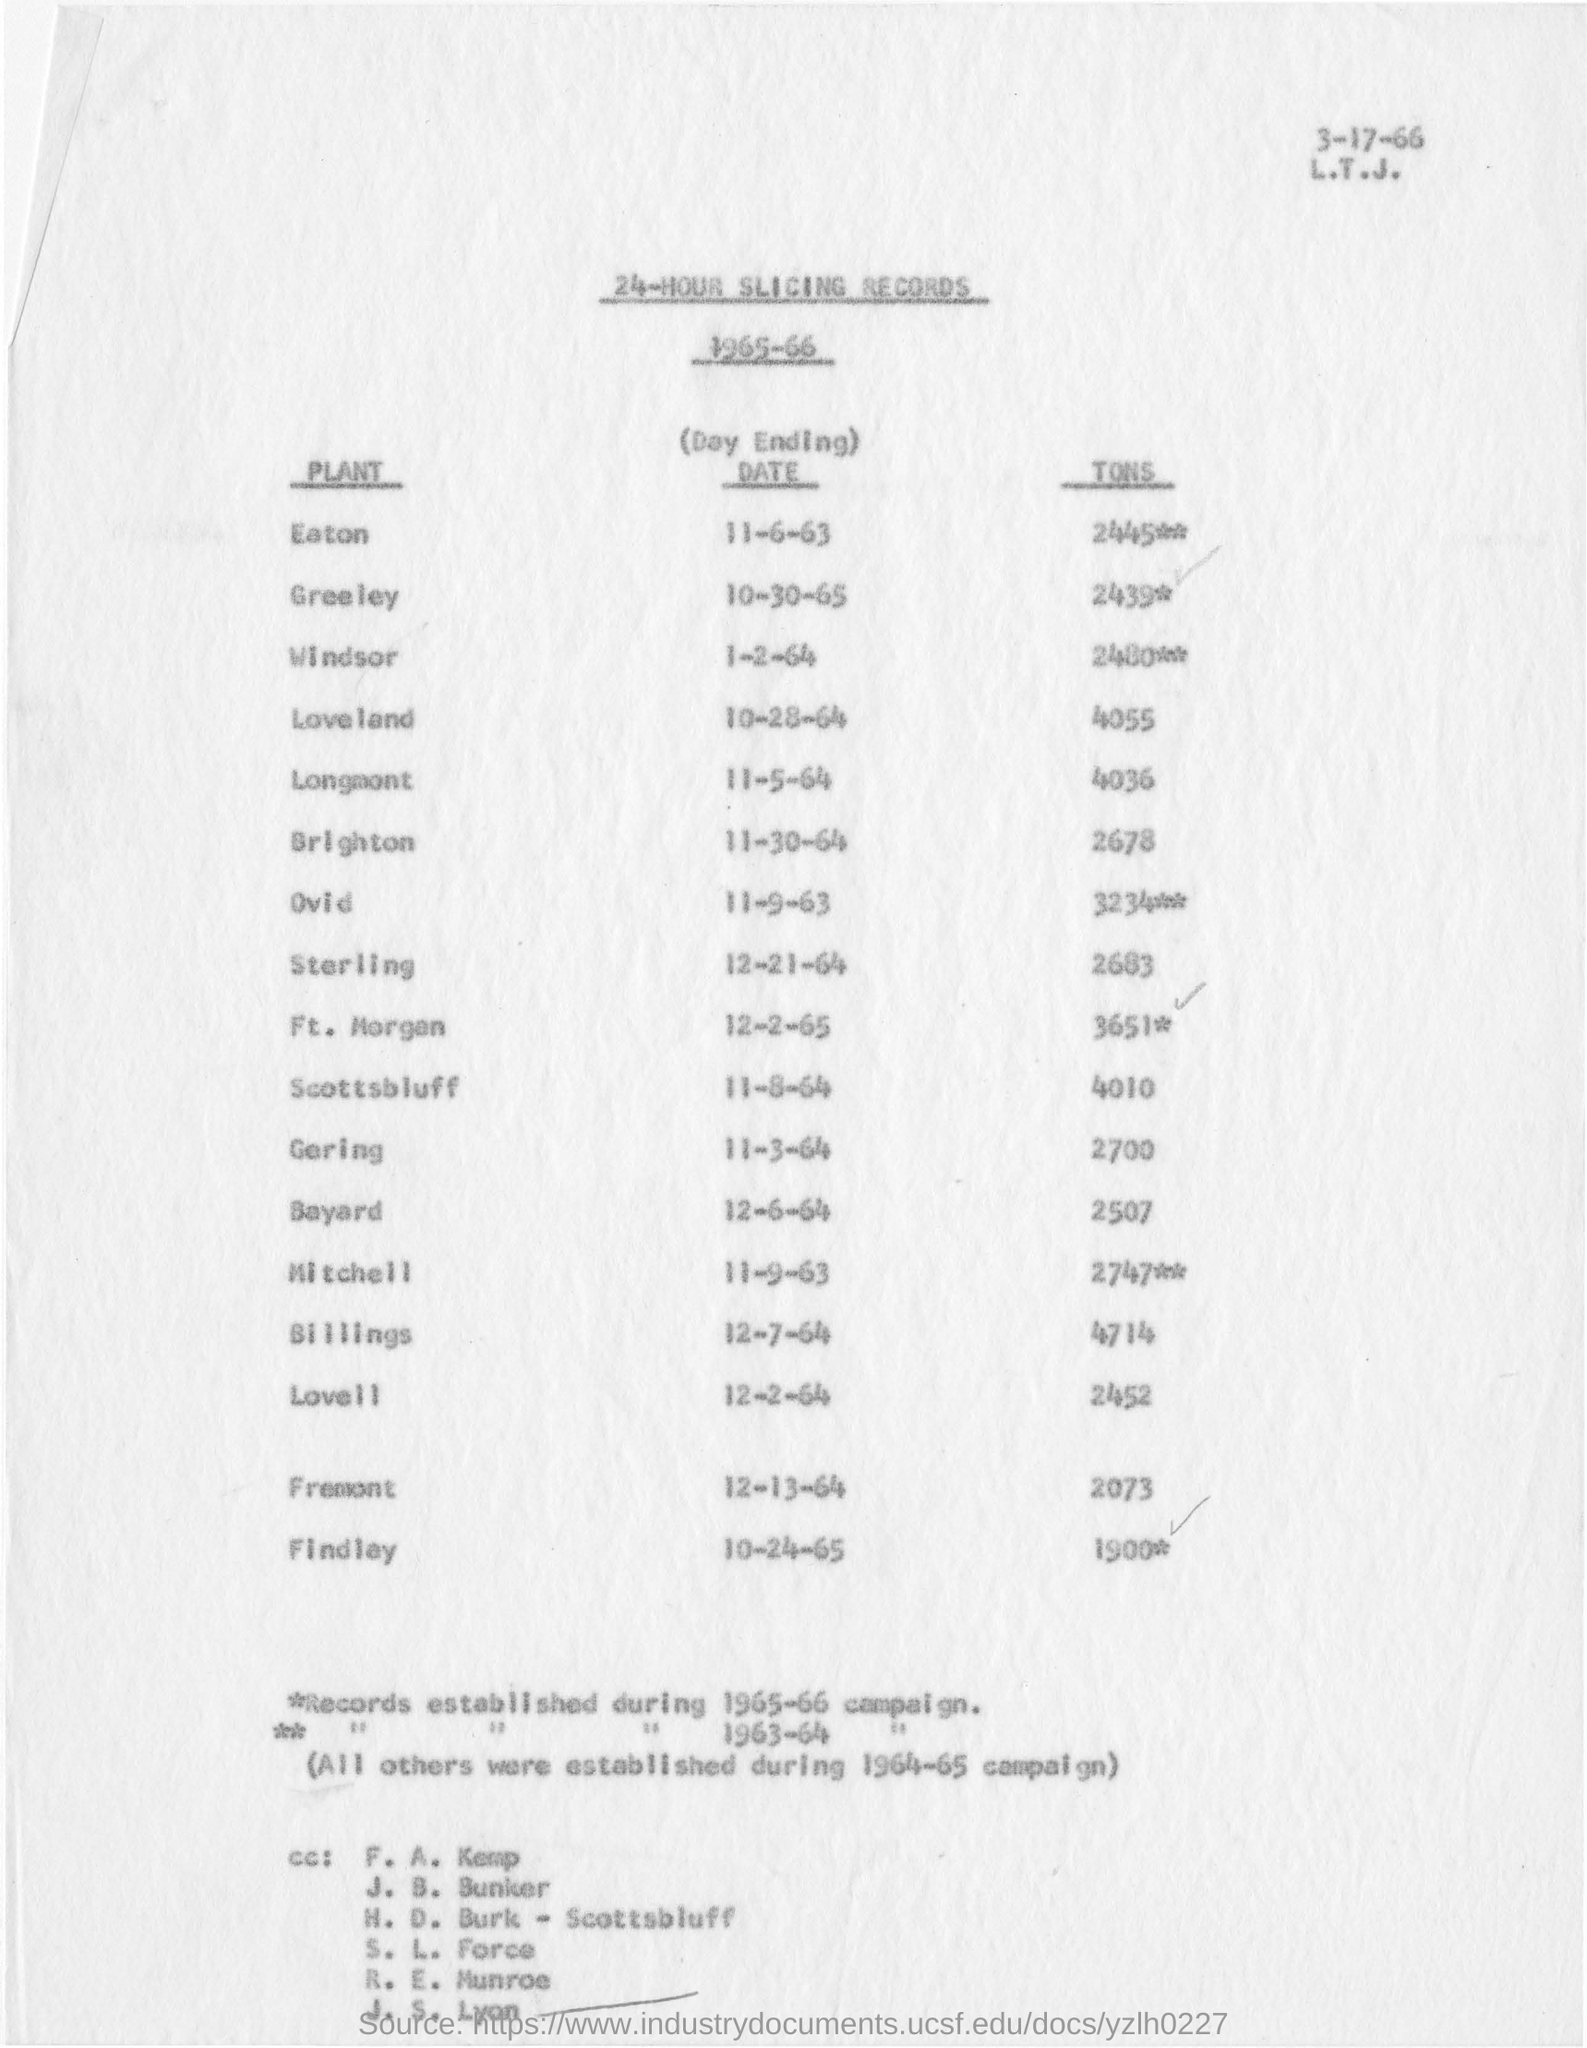What is the date mentioned at the top?
Your response must be concise. 3-17-66. What is the  DATE of Sterling?
Offer a terse response. 12-21-64. How many tons for Lovell?
Keep it short and to the point. 2452. Which Plant's Day Ending date is on 11-6-63?
Give a very brief answer. EATON. 